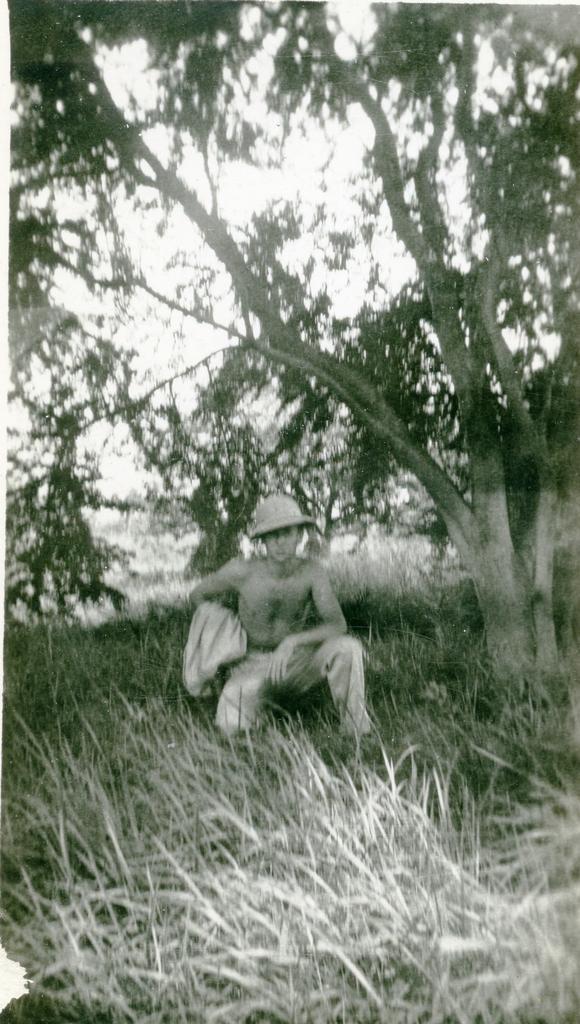How would you summarize this image in a sentence or two? It is an old image there is a man sitting on the grass in a squatting position and beside the man there is a big tree. 